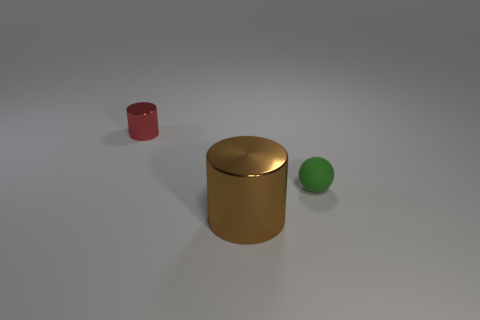Add 1 large cylinders. How many objects exist? 4 Subtract all cylinders. How many objects are left? 1 Add 3 large brown metallic things. How many large brown metallic things are left? 4 Add 2 big objects. How many big objects exist? 3 Subtract 0 green cylinders. How many objects are left? 3 Subtract all big shiny cylinders. Subtract all spheres. How many objects are left? 1 